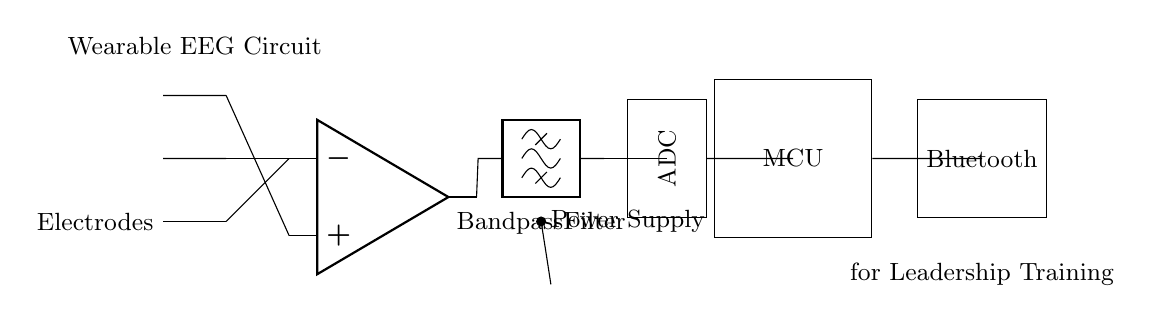What are the primary components in this circuit? The primary components visible in the circuit include EEG electrodes, an instrumentation amplifier, a bandpass filter, an ADC, a microcontroller, and a Bluetooth module. Each of these components plays a crucial role in processing and transmitting brainwave data.
Answer: Electrodes, amplifier, filter, ADC, microcontroller, Bluetooth What is the function of the bandpass filter? The bandpass filter selectively allows signals within a certain frequency range to pass through while attenuating frequencies outside that range. In this circuit, it helps to isolate the relevant brainwave frequencies for accurate analysis.
Answer: Selective frequency filtering Which component is responsible for data conversion? The ADC (Analog to Digital Converter) converts the analog signals from the bandpass filter into digital signals that can be processed by the microcontroller. This process is essential for digitizing the brainwave data collected from the EEG electrodes.
Answer: ADC What connects the instrumentation amplifier and the bandpass filter? The connection between the instrumentation amplifier and the bandpass filter is made via a short wire, indicating that the output of the amplifier directly feeds into the input of the filter. This direct connection is crucial for signal flow.
Answer: A short wire How does the circuit transmit data wirelessly? The circuit transmits data wirelessly through the Bluetooth module, which is directly connected to the microcontroller. This module enables communication with other devices, facilitating the sharing of brainwave data collected during leadership training.
Answer: Bluetooth module What power supply is used for the circuit? The circuit uses a battery as its power supply, as indicated by the battery symbol in the diagram. This design is typical for wearable devices which require portable and compact power sources to operate effectively.
Answer: Battery What is the purpose of the EEG electrodes in this circuit? The EEG electrodes are designed to detect and collect electrical activity from the brain. They serve as the sensors that pick up brainwave signals, which are essential for monitoring the participants' mental states during leadership training sessions.
Answer: Detect brain activity 